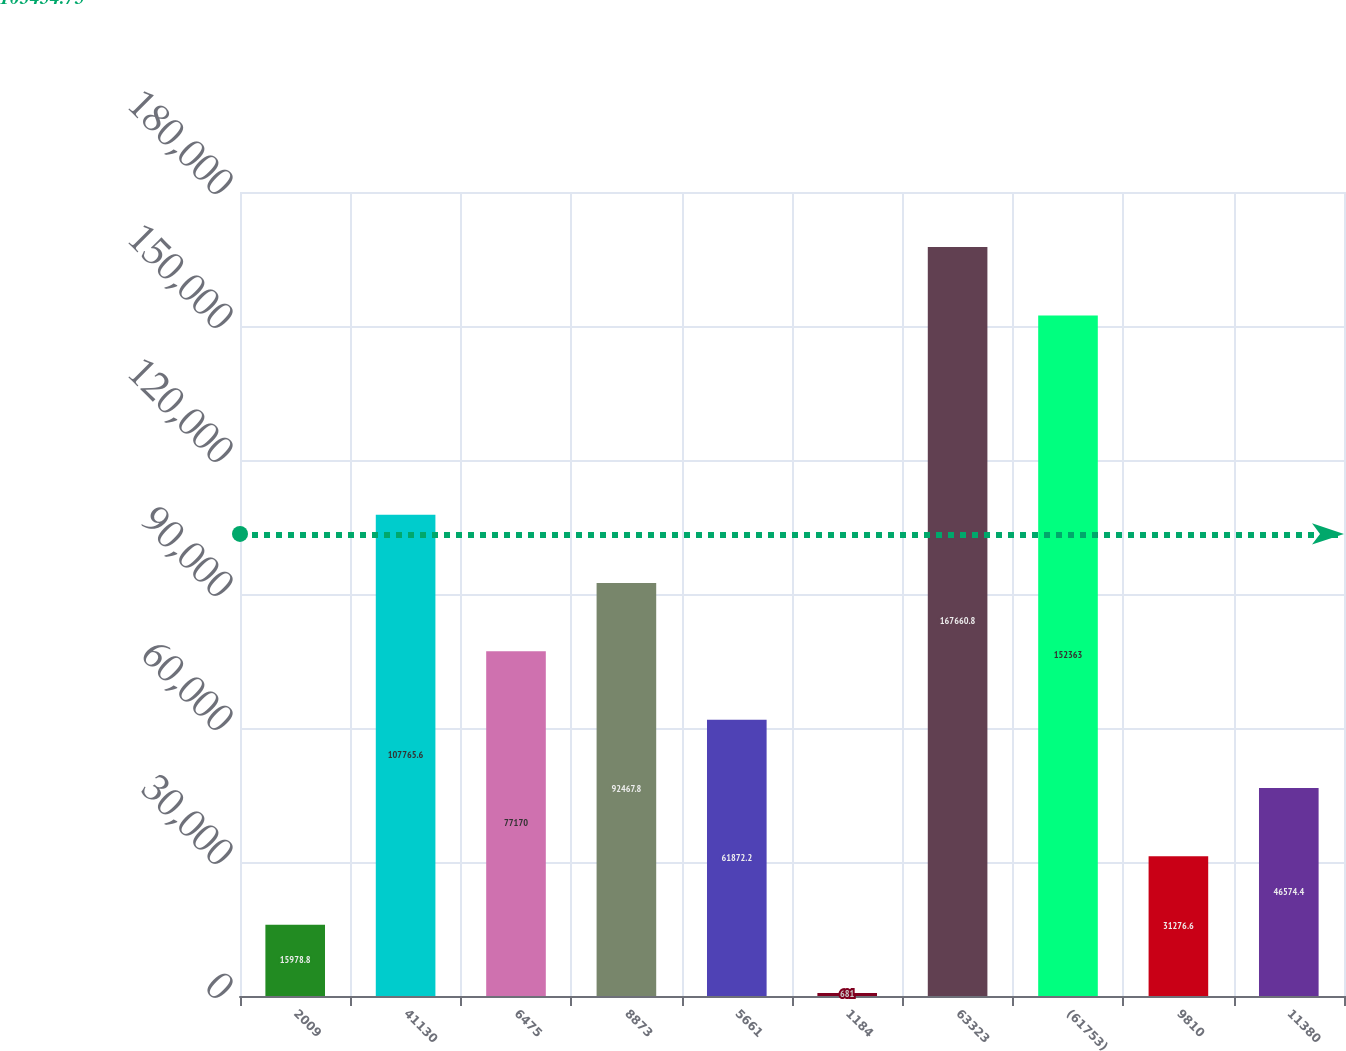Convert chart. <chart><loc_0><loc_0><loc_500><loc_500><bar_chart><fcel>2009<fcel>41130<fcel>6475<fcel>8873<fcel>5661<fcel>1184<fcel>63323<fcel>(61753)<fcel>9810<fcel>11380<nl><fcel>15978.8<fcel>107766<fcel>77170<fcel>92467.8<fcel>61872.2<fcel>681<fcel>167661<fcel>152363<fcel>31276.6<fcel>46574.4<nl></chart> 